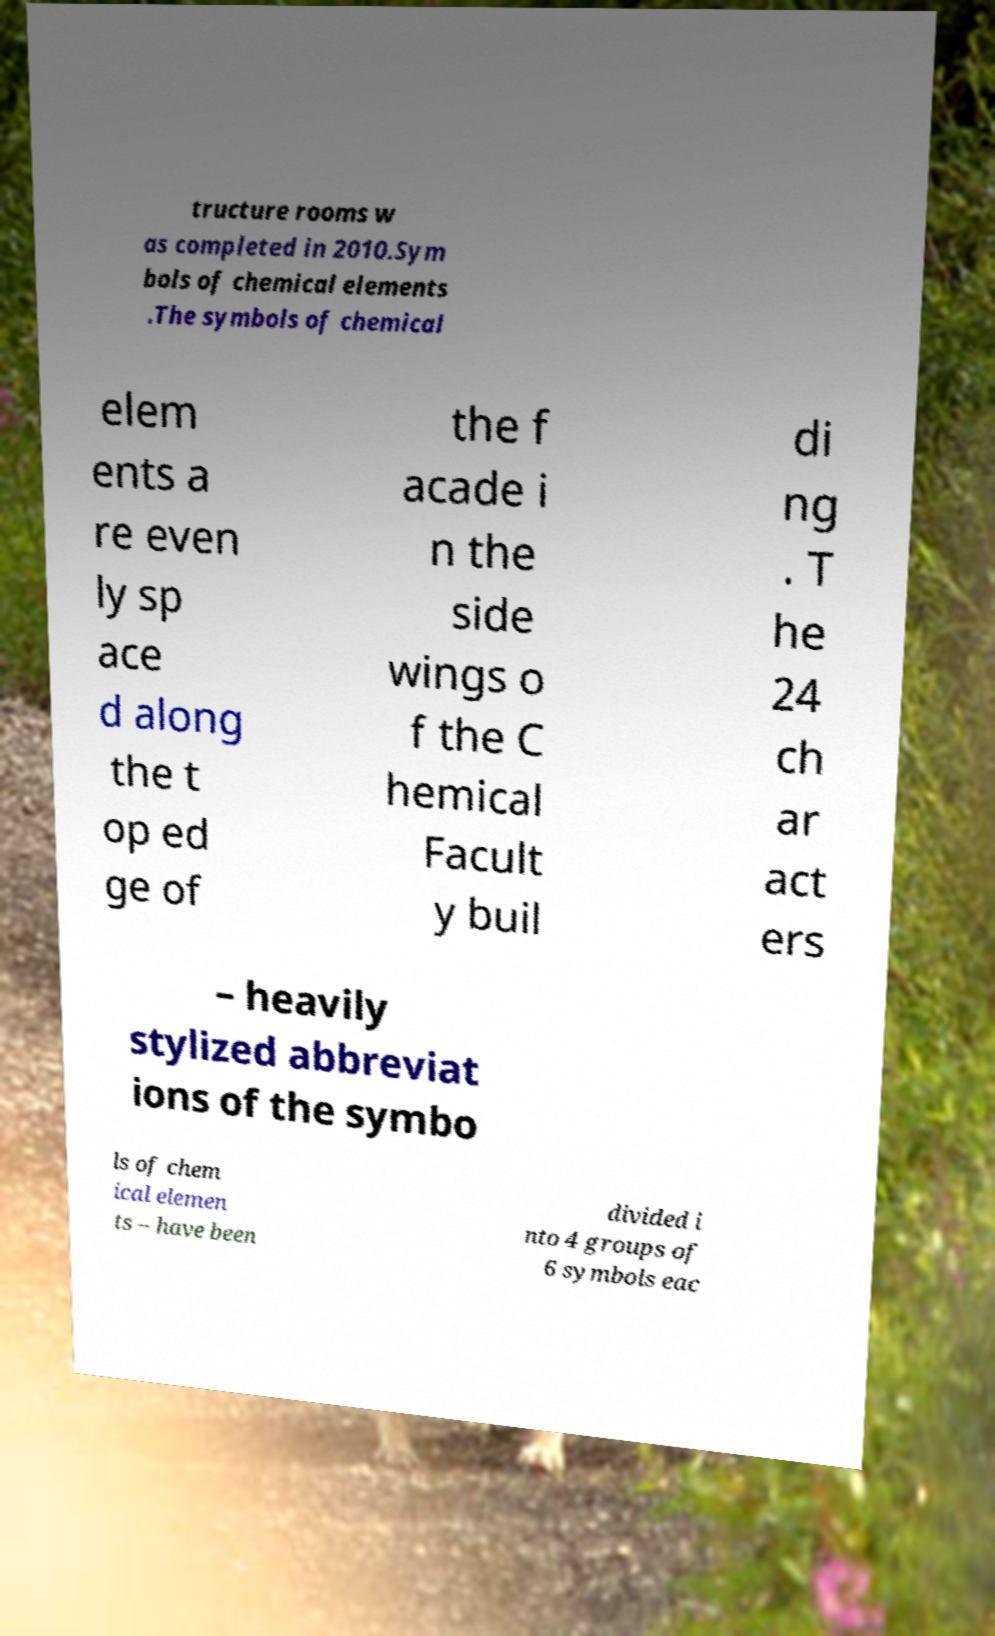There's text embedded in this image that I need extracted. Can you transcribe it verbatim? tructure rooms w as completed in 2010.Sym bols of chemical elements .The symbols of chemical elem ents a re even ly sp ace d along the t op ed ge of the f acade i n the side wings o f the C hemical Facult y buil di ng . T he 24 ch ar act ers – heavily stylized abbreviat ions of the symbo ls of chem ical elemen ts – have been divided i nto 4 groups of 6 symbols eac 